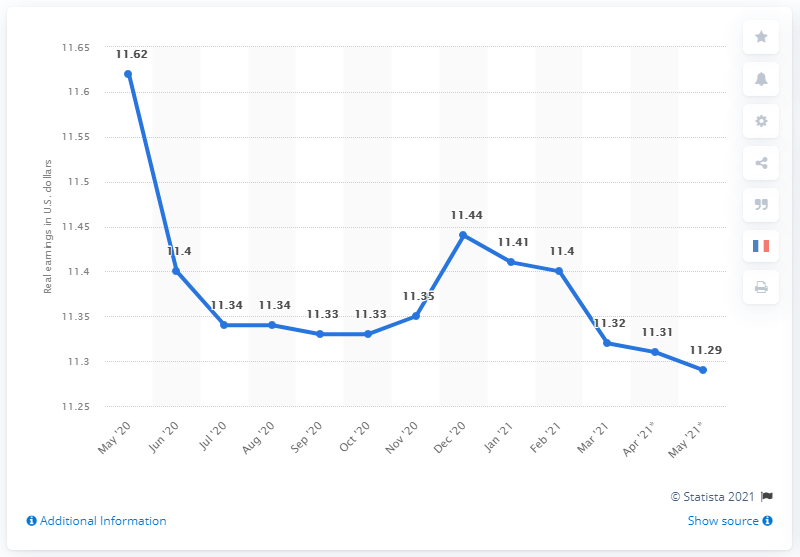Highlight a few significant elements in this photo. In May 21, the earnings were 11.29. The earnings difference between May 20 and May 21 was 0.33. In May 2021, the average hourly earnings of all employees in the United States was 11.29 U.S. dollars. 